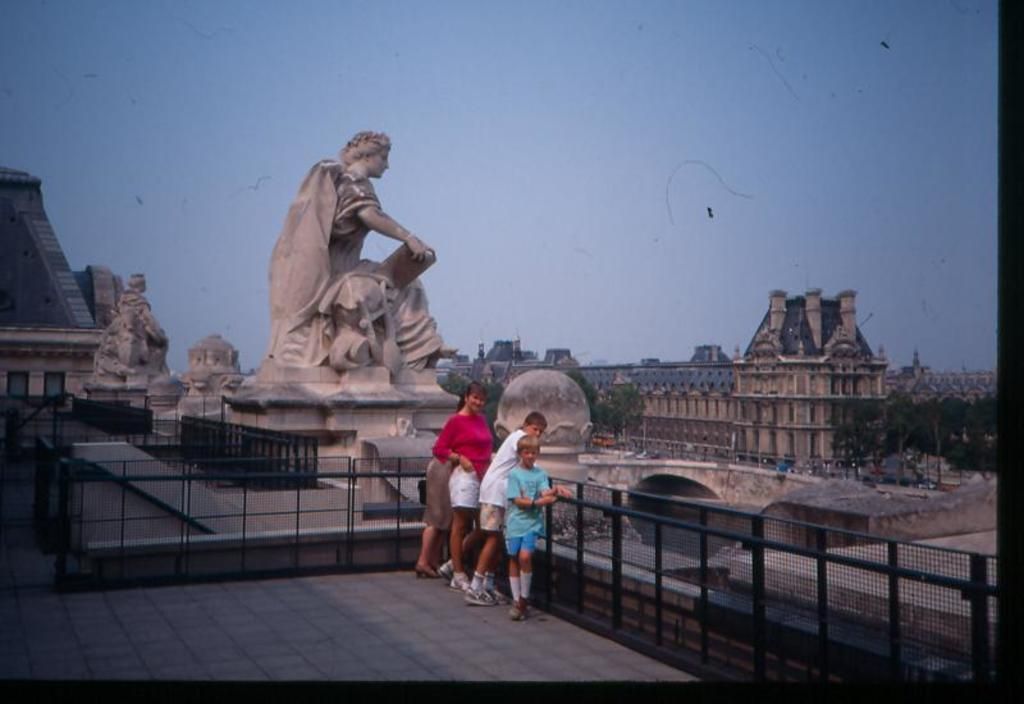How many people are present in the image? There are four people standing in the image. What surface are the people standing on? The people are standing on the floor. What structures can be seen in the image? There are fences, statues, and buildings in the image. What type of vegetation is present in the image? There are trees in the image. What other objects can be seen in the image? There are poles and some unspecified objects in the image. What can be seen in the background of the image? The sky is visible in the background of the image. Can you tell me how many boats are docked at the harbor in the image? There is no harbor or boats present in the image. What type of stone is used to construct the mountain in the image? There is no mountain present in the image. 